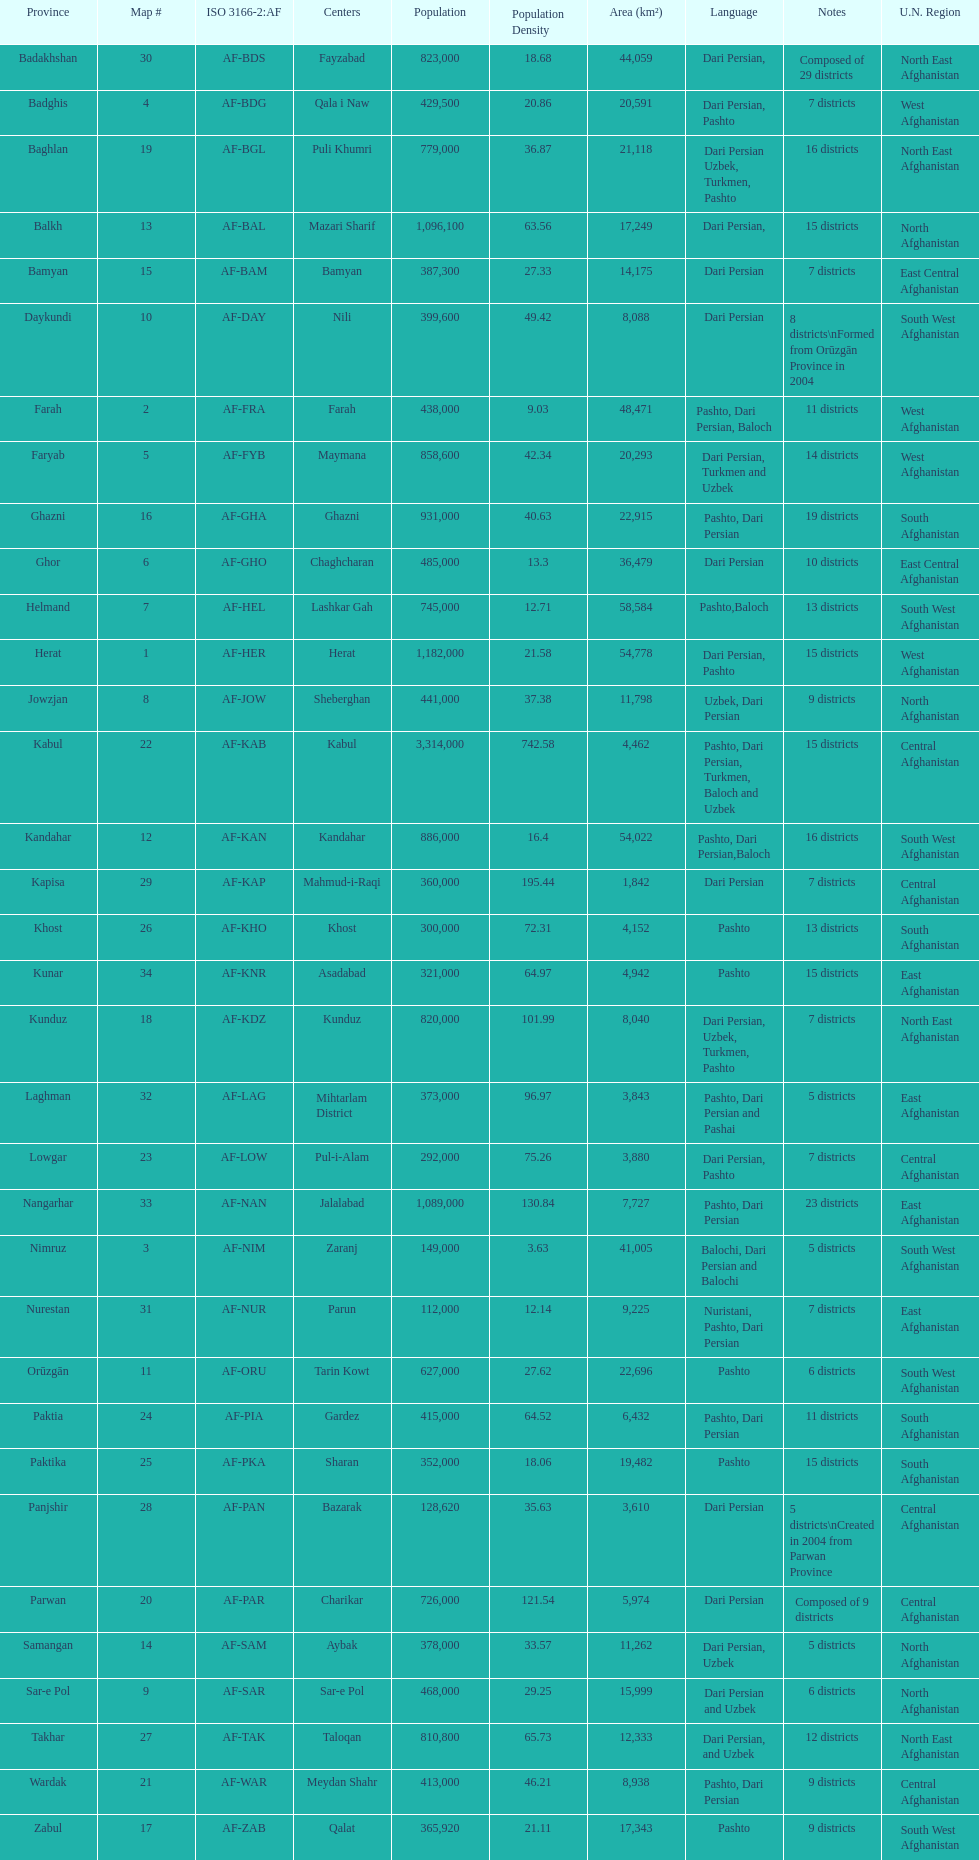How many provinces have pashto as one of their languages 20. 